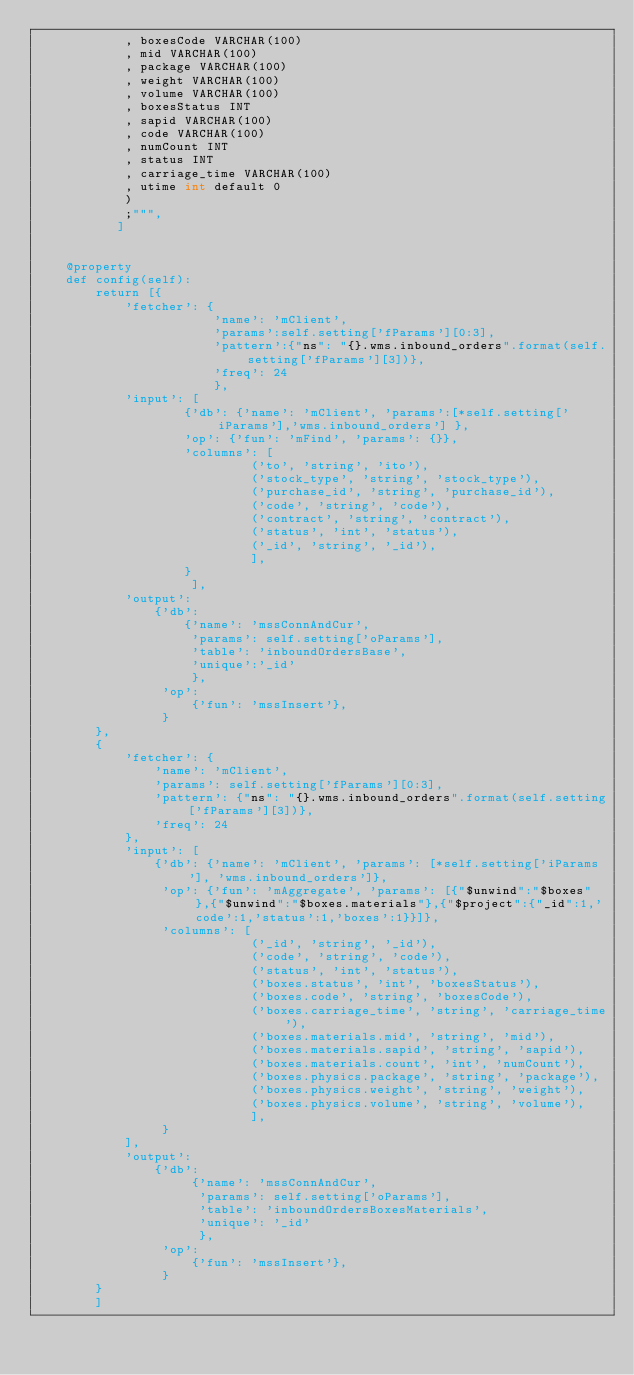Convert code to text. <code><loc_0><loc_0><loc_500><loc_500><_Python_>            , boxesCode VARCHAR(100)
            , mid VARCHAR(100)
            , package VARCHAR(100)
            , weight VARCHAR(100)
            , volume VARCHAR(100)
            , boxesStatus INT
            , sapid VARCHAR(100)
            , code VARCHAR(100)
            , numCount INT
            , status INT
            , carriage_time VARCHAR(100)
            , utime int default 0
            )
            ;""",
           ]


    @property
    def config(self):
        return [{
            'fetcher': {
                        'name': 'mClient',
                        'params':self.setting['fParams'][0:3],
                        'pattern':{"ns": "{}.wms.inbound_orders".format(self.setting['fParams'][3])},
                        'freq': 24
                        },
            'input': [
                    {'db': {'name': 'mClient', 'params':[*self.setting['iParams'],'wms.inbound_orders'] },
                    'op': {'fun': 'mFind', 'params': {}},
                    'columns': [
                             ('to', 'string', 'ito'),
                             ('stock_type', 'string', 'stock_type'),
                             ('purchase_id', 'string', 'purchase_id'),
                             ('code', 'string', 'code'),
                             ('contract', 'string', 'contract'),
                             ('status', 'int', 'status'),
                             ('_id', 'string', '_id'),
                             ],
                    }
                     ],
            'output':
                {'db':
                    {'name': 'mssConnAndCur',
                     'params': self.setting['oParams'],
                     'table': 'inboundOrdersBase',
                     'unique':'_id'
                     },
                 'op':
                     {'fun': 'mssInsert'},
                 }
        },
        {
            'fetcher': {
                'name': 'mClient',
                'params': self.setting['fParams'][0:3],
                'pattern': {"ns": "{}.wms.inbound_orders".format(self.setting['fParams'][3])},
                'freq': 24
            },
            'input': [
                {'db': {'name': 'mClient', 'params': [*self.setting['iParams'], 'wms.inbound_orders']},
                 'op': {'fun': 'mAggregate', 'params': [{"$unwind":"$boxes"},{"$unwind":"$boxes.materials"},{"$project":{"_id":1,'code':1,'status':1,'boxes':1}}]},
                 'columns': [
                             ('_id', 'string', '_id'),
                             ('code', 'string', 'code'),
                             ('status', 'int', 'status'),
                             ('boxes.status', 'int', 'boxesStatus'),
                             ('boxes.code', 'string', 'boxesCode'),
                             ('boxes.carriage_time', 'string', 'carriage_time'),
                             ('boxes.materials.mid', 'string', 'mid'),
                             ('boxes.materials.sapid', 'string', 'sapid'),
                             ('boxes.materials.count', 'int', 'numCount'),
                             ('boxes.physics.package', 'string', 'package'),
                             ('boxes.physics.weight', 'string', 'weight'),
                             ('boxes.physics.volume', 'string', 'volume'),
                             ],
                 }
            ],
            'output':
                {'db':
                     {'name': 'mssConnAndCur',
                      'params': self.setting['oParams'],
                      'table': 'inboundOrdersBoxesMaterials',
                      'unique': '_id'
                      },
                 'op':
                     {'fun': 'mssInsert'},
                 }
        }
        ]


</code> 